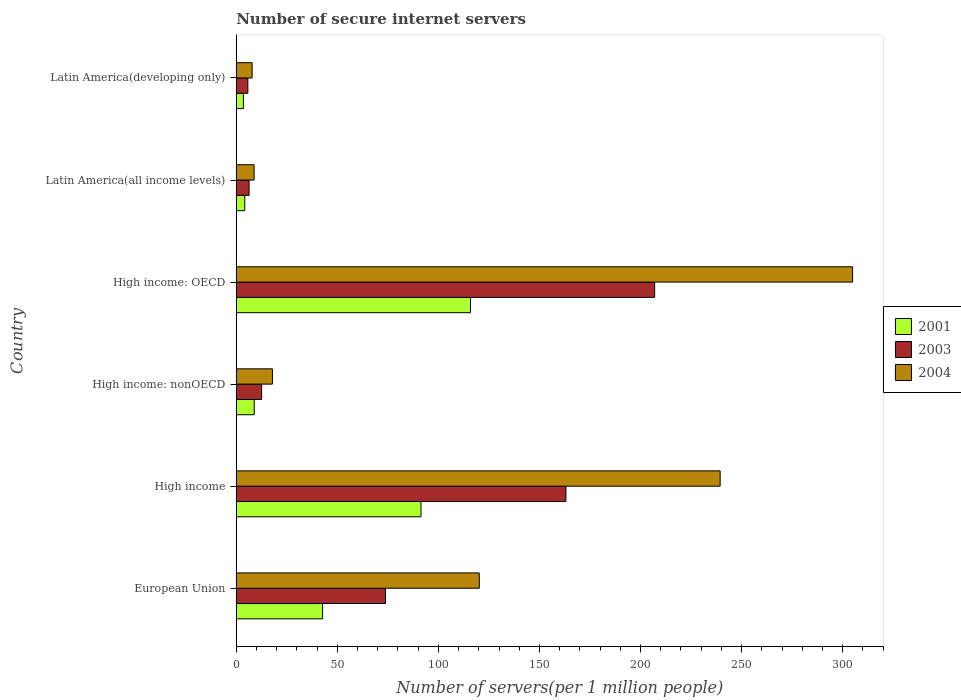How many groups of bars are there?
Your answer should be very brief. 6. What is the number of secure internet servers in 2004 in High income: nonOECD?
Your response must be concise. 17.9. Across all countries, what is the maximum number of secure internet servers in 2001?
Your answer should be compact. 115.88. Across all countries, what is the minimum number of secure internet servers in 2004?
Ensure brevity in your answer.  7.85. In which country was the number of secure internet servers in 2004 maximum?
Ensure brevity in your answer.  High income: OECD. In which country was the number of secure internet servers in 2003 minimum?
Make the answer very short. Latin America(developing only). What is the total number of secure internet servers in 2001 in the graph?
Your answer should be compact. 266.59. What is the difference between the number of secure internet servers in 2001 in High income and that in Latin America(developing only)?
Ensure brevity in your answer.  87.87. What is the difference between the number of secure internet servers in 2001 in Latin America(all income levels) and the number of secure internet servers in 2004 in High income: nonOECD?
Make the answer very short. -13.69. What is the average number of secure internet servers in 2004 per country?
Make the answer very short. 116.52. What is the difference between the number of secure internet servers in 2004 and number of secure internet servers in 2001 in European Union?
Make the answer very short. 77.51. What is the ratio of the number of secure internet servers in 2004 in High income: nonOECD to that in Latin America(developing only)?
Ensure brevity in your answer.  2.28. Is the difference between the number of secure internet servers in 2004 in High income: OECD and Latin America(all income levels) greater than the difference between the number of secure internet servers in 2001 in High income: OECD and Latin America(all income levels)?
Your answer should be compact. Yes. What is the difference between the highest and the second highest number of secure internet servers in 2003?
Your answer should be very brief. 43.9. What is the difference between the highest and the lowest number of secure internet servers in 2003?
Provide a short and direct response. 201.25. In how many countries, is the number of secure internet servers in 2004 greater than the average number of secure internet servers in 2004 taken over all countries?
Give a very brief answer. 3. Is the sum of the number of secure internet servers in 2001 in High income: OECD and Latin America(all income levels) greater than the maximum number of secure internet servers in 2004 across all countries?
Provide a succinct answer. No. What does the 2nd bar from the bottom in High income: nonOECD represents?
Make the answer very short. 2003. Is it the case that in every country, the sum of the number of secure internet servers in 2003 and number of secure internet servers in 2004 is greater than the number of secure internet servers in 2001?
Your answer should be compact. Yes. Where does the legend appear in the graph?
Make the answer very short. Center right. How are the legend labels stacked?
Your answer should be compact. Vertical. What is the title of the graph?
Provide a short and direct response. Number of secure internet servers. Does "1977" appear as one of the legend labels in the graph?
Give a very brief answer. No. What is the label or title of the X-axis?
Provide a short and direct response. Number of servers(per 1 million people). What is the label or title of the Y-axis?
Provide a succinct answer. Country. What is the Number of servers(per 1 million people) of 2001 in European Union?
Your answer should be compact. 42.71. What is the Number of servers(per 1 million people) of 2003 in European Union?
Offer a terse response. 73.83. What is the Number of servers(per 1 million people) of 2004 in European Union?
Your response must be concise. 120.23. What is the Number of servers(per 1 million people) in 2001 in High income?
Make the answer very short. 91.39. What is the Number of servers(per 1 million people) of 2003 in High income?
Keep it short and to the point. 163.09. What is the Number of servers(per 1 million people) in 2004 in High income?
Offer a terse response. 239.39. What is the Number of servers(per 1 million people) of 2001 in High income: nonOECD?
Your response must be concise. 8.88. What is the Number of servers(per 1 million people) in 2003 in High income: nonOECD?
Make the answer very short. 12.55. What is the Number of servers(per 1 million people) in 2004 in High income: nonOECD?
Make the answer very short. 17.9. What is the Number of servers(per 1 million people) of 2001 in High income: OECD?
Your answer should be compact. 115.88. What is the Number of servers(per 1 million people) of 2003 in High income: OECD?
Offer a very short reply. 206.98. What is the Number of servers(per 1 million people) in 2004 in High income: OECD?
Keep it short and to the point. 304.92. What is the Number of servers(per 1 million people) of 2001 in Latin America(all income levels)?
Your answer should be compact. 4.21. What is the Number of servers(per 1 million people) in 2003 in Latin America(all income levels)?
Your answer should be very brief. 6.35. What is the Number of servers(per 1 million people) of 2004 in Latin America(all income levels)?
Offer a very short reply. 8.83. What is the Number of servers(per 1 million people) in 2001 in Latin America(developing only)?
Your answer should be very brief. 3.52. What is the Number of servers(per 1 million people) in 2003 in Latin America(developing only)?
Your answer should be very brief. 5.73. What is the Number of servers(per 1 million people) in 2004 in Latin America(developing only)?
Give a very brief answer. 7.85. Across all countries, what is the maximum Number of servers(per 1 million people) in 2001?
Your answer should be compact. 115.88. Across all countries, what is the maximum Number of servers(per 1 million people) in 2003?
Provide a short and direct response. 206.98. Across all countries, what is the maximum Number of servers(per 1 million people) in 2004?
Keep it short and to the point. 304.92. Across all countries, what is the minimum Number of servers(per 1 million people) of 2001?
Offer a terse response. 3.52. Across all countries, what is the minimum Number of servers(per 1 million people) of 2003?
Provide a succinct answer. 5.73. Across all countries, what is the minimum Number of servers(per 1 million people) in 2004?
Your response must be concise. 7.85. What is the total Number of servers(per 1 million people) of 2001 in the graph?
Give a very brief answer. 266.59. What is the total Number of servers(per 1 million people) of 2003 in the graph?
Provide a short and direct response. 468.53. What is the total Number of servers(per 1 million people) in 2004 in the graph?
Give a very brief answer. 699.12. What is the difference between the Number of servers(per 1 million people) of 2001 in European Union and that in High income?
Your answer should be compact. -48.68. What is the difference between the Number of servers(per 1 million people) in 2003 in European Union and that in High income?
Provide a short and direct response. -89.26. What is the difference between the Number of servers(per 1 million people) in 2004 in European Union and that in High income?
Offer a very short reply. -119.16. What is the difference between the Number of servers(per 1 million people) of 2001 in European Union and that in High income: nonOECD?
Ensure brevity in your answer.  33.84. What is the difference between the Number of servers(per 1 million people) in 2003 in European Union and that in High income: nonOECD?
Offer a terse response. 61.28. What is the difference between the Number of servers(per 1 million people) in 2004 in European Union and that in High income: nonOECD?
Your answer should be compact. 102.32. What is the difference between the Number of servers(per 1 million people) in 2001 in European Union and that in High income: OECD?
Make the answer very short. -73.16. What is the difference between the Number of servers(per 1 million people) in 2003 in European Union and that in High income: OECD?
Make the answer very short. -133.16. What is the difference between the Number of servers(per 1 million people) in 2004 in European Union and that in High income: OECD?
Give a very brief answer. -184.7. What is the difference between the Number of servers(per 1 million people) in 2001 in European Union and that in Latin America(all income levels)?
Your answer should be very brief. 38.51. What is the difference between the Number of servers(per 1 million people) in 2003 in European Union and that in Latin America(all income levels)?
Ensure brevity in your answer.  67.48. What is the difference between the Number of servers(per 1 million people) in 2004 in European Union and that in Latin America(all income levels)?
Ensure brevity in your answer.  111.4. What is the difference between the Number of servers(per 1 million people) of 2001 in European Union and that in Latin America(developing only)?
Offer a terse response. 39.19. What is the difference between the Number of servers(per 1 million people) of 2003 in European Union and that in Latin America(developing only)?
Offer a very short reply. 68.1. What is the difference between the Number of servers(per 1 million people) in 2004 in European Union and that in Latin America(developing only)?
Offer a terse response. 112.38. What is the difference between the Number of servers(per 1 million people) of 2001 in High income and that in High income: nonOECD?
Give a very brief answer. 82.52. What is the difference between the Number of servers(per 1 million people) of 2003 in High income and that in High income: nonOECD?
Your answer should be very brief. 150.54. What is the difference between the Number of servers(per 1 million people) of 2004 in High income and that in High income: nonOECD?
Offer a very short reply. 221.49. What is the difference between the Number of servers(per 1 million people) in 2001 in High income and that in High income: OECD?
Provide a short and direct response. -24.49. What is the difference between the Number of servers(per 1 million people) in 2003 in High income and that in High income: OECD?
Give a very brief answer. -43.9. What is the difference between the Number of servers(per 1 million people) in 2004 in High income and that in High income: OECD?
Your response must be concise. -65.53. What is the difference between the Number of servers(per 1 million people) in 2001 in High income and that in Latin America(all income levels)?
Ensure brevity in your answer.  87.18. What is the difference between the Number of servers(per 1 million people) of 2003 in High income and that in Latin America(all income levels)?
Keep it short and to the point. 156.74. What is the difference between the Number of servers(per 1 million people) of 2004 in High income and that in Latin America(all income levels)?
Offer a very short reply. 230.56. What is the difference between the Number of servers(per 1 million people) in 2001 in High income and that in Latin America(developing only)?
Your answer should be compact. 87.87. What is the difference between the Number of servers(per 1 million people) in 2003 in High income and that in Latin America(developing only)?
Offer a very short reply. 157.36. What is the difference between the Number of servers(per 1 million people) in 2004 in High income and that in Latin America(developing only)?
Keep it short and to the point. 231.54. What is the difference between the Number of servers(per 1 million people) in 2001 in High income: nonOECD and that in High income: OECD?
Your answer should be compact. -107. What is the difference between the Number of servers(per 1 million people) of 2003 in High income: nonOECD and that in High income: OECD?
Your response must be concise. -194.43. What is the difference between the Number of servers(per 1 million people) of 2004 in High income: nonOECD and that in High income: OECD?
Keep it short and to the point. -287.02. What is the difference between the Number of servers(per 1 million people) in 2001 in High income: nonOECD and that in Latin America(all income levels)?
Provide a succinct answer. 4.67. What is the difference between the Number of servers(per 1 million people) in 2003 in High income: nonOECD and that in Latin America(all income levels)?
Give a very brief answer. 6.2. What is the difference between the Number of servers(per 1 million people) in 2004 in High income: nonOECD and that in Latin America(all income levels)?
Your response must be concise. 9.07. What is the difference between the Number of servers(per 1 million people) of 2001 in High income: nonOECD and that in Latin America(developing only)?
Provide a succinct answer. 5.35. What is the difference between the Number of servers(per 1 million people) of 2003 in High income: nonOECD and that in Latin America(developing only)?
Provide a short and direct response. 6.82. What is the difference between the Number of servers(per 1 million people) of 2004 in High income: nonOECD and that in Latin America(developing only)?
Provide a short and direct response. 10.05. What is the difference between the Number of servers(per 1 million people) of 2001 in High income: OECD and that in Latin America(all income levels)?
Offer a terse response. 111.67. What is the difference between the Number of servers(per 1 million people) in 2003 in High income: OECD and that in Latin America(all income levels)?
Ensure brevity in your answer.  200.64. What is the difference between the Number of servers(per 1 million people) in 2004 in High income: OECD and that in Latin America(all income levels)?
Provide a succinct answer. 296.09. What is the difference between the Number of servers(per 1 million people) of 2001 in High income: OECD and that in Latin America(developing only)?
Give a very brief answer. 112.36. What is the difference between the Number of servers(per 1 million people) in 2003 in High income: OECD and that in Latin America(developing only)?
Your response must be concise. 201.25. What is the difference between the Number of servers(per 1 million people) of 2004 in High income: OECD and that in Latin America(developing only)?
Your answer should be compact. 297.07. What is the difference between the Number of servers(per 1 million people) in 2001 in Latin America(all income levels) and that in Latin America(developing only)?
Your response must be concise. 0.69. What is the difference between the Number of servers(per 1 million people) in 2003 in Latin America(all income levels) and that in Latin America(developing only)?
Make the answer very short. 0.61. What is the difference between the Number of servers(per 1 million people) in 2004 in Latin America(all income levels) and that in Latin America(developing only)?
Provide a succinct answer. 0.98. What is the difference between the Number of servers(per 1 million people) in 2001 in European Union and the Number of servers(per 1 million people) in 2003 in High income?
Your answer should be compact. -120.37. What is the difference between the Number of servers(per 1 million people) in 2001 in European Union and the Number of servers(per 1 million people) in 2004 in High income?
Give a very brief answer. -196.68. What is the difference between the Number of servers(per 1 million people) in 2003 in European Union and the Number of servers(per 1 million people) in 2004 in High income?
Offer a terse response. -165.56. What is the difference between the Number of servers(per 1 million people) of 2001 in European Union and the Number of servers(per 1 million people) of 2003 in High income: nonOECD?
Ensure brevity in your answer.  30.16. What is the difference between the Number of servers(per 1 million people) in 2001 in European Union and the Number of servers(per 1 million people) in 2004 in High income: nonOECD?
Provide a succinct answer. 24.81. What is the difference between the Number of servers(per 1 million people) in 2003 in European Union and the Number of servers(per 1 million people) in 2004 in High income: nonOECD?
Offer a terse response. 55.93. What is the difference between the Number of servers(per 1 million people) of 2001 in European Union and the Number of servers(per 1 million people) of 2003 in High income: OECD?
Make the answer very short. -164.27. What is the difference between the Number of servers(per 1 million people) of 2001 in European Union and the Number of servers(per 1 million people) of 2004 in High income: OECD?
Your answer should be compact. -262.21. What is the difference between the Number of servers(per 1 million people) in 2003 in European Union and the Number of servers(per 1 million people) in 2004 in High income: OECD?
Ensure brevity in your answer.  -231.09. What is the difference between the Number of servers(per 1 million people) of 2001 in European Union and the Number of servers(per 1 million people) of 2003 in Latin America(all income levels)?
Provide a short and direct response. 36.37. What is the difference between the Number of servers(per 1 million people) in 2001 in European Union and the Number of servers(per 1 million people) in 2004 in Latin America(all income levels)?
Offer a terse response. 33.88. What is the difference between the Number of servers(per 1 million people) of 2003 in European Union and the Number of servers(per 1 million people) of 2004 in Latin America(all income levels)?
Keep it short and to the point. 65. What is the difference between the Number of servers(per 1 million people) in 2001 in European Union and the Number of servers(per 1 million people) in 2003 in Latin America(developing only)?
Provide a succinct answer. 36.98. What is the difference between the Number of servers(per 1 million people) in 2001 in European Union and the Number of servers(per 1 million people) in 2004 in Latin America(developing only)?
Ensure brevity in your answer.  34.86. What is the difference between the Number of servers(per 1 million people) in 2003 in European Union and the Number of servers(per 1 million people) in 2004 in Latin America(developing only)?
Provide a short and direct response. 65.98. What is the difference between the Number of servers(per 1 million people) in 2001 in High income and the Number of servers(per 1 million people) in 2003 in High income: nonOECD?
Provide a short and direct response. 78.84. What is the difference between the Number of servers(per 1 million people) of 2001 in High income and the Number of servers(per 1 million people) of 2004 in High income: nonOECD?
Your answer should be compact. 73.49. What is the difference between the Number of servers(per 1 million people) in 2003 in High income and the Number of servers(per 1 million people) in 2004 in High income: nonOECD?
Make the answer very short. 145.18. What is the difference between the Number of servers(per 1 million people) in 2001 in High income and the Number of servers(per 1 million people) in 2003 in High income: OECD?
Give a very brief answer. -115.59. What is the difference between the Number of servers(per 1 million people) of 2001 in High income and the Number of servers(per 1 million people) of 2004 in High income: OECD?
Offer a terse response. -213.53. What is the difference between the Number of servers(per 1 million people) of 2003 in High income and the Number of servers(per 1 million people) of 2004 in High income: OECD?
Offer a very short reply. -141.83. What is the difference between the Number of servers(per 1 million people) in 2001 in High income and the Number of servers(per 1 million people) in 2003 in Latin America(all income levels)?
Your response must be concise. 85.05. What is the difference between the Number of servers(per 1 million people) in 2001 in High income and the Number of servers(per 1 million people) in 2004 in Latin America(all income levels)?
Offer a terse response. 82.56. What is the difference between the Number of servers(per 1 million people) of 2003 in High income and the Number of servers(per 1 million people) of 2004 in Latin America(all income levels)?
Your answer should be compact. 154.26. What is the difference between the Number of servers(per 1 million people) in 2001 in High income and the Number of servers(per 1 million people) in 2003 in Latin America(developing only)?
Your answer should be very brief. 85.66. What is the difference between the Number of servers(per 1 million people) in 2001 in High income and the Number of servers(per 1 million people) in 2004 in Latin America(developing only)?
Provide a succinct answer. 83.54. What is the difference between the Number of servers(per 1 million people) in 2003 in High income and the Number of servers(per 1 million people) in 2004 in Latin America(developing only)?
Offer a very short reply. 155.24. What is the difference between the Number of servers(per 1 million people) in 2001 in High income: nonOECD and the Number of servers(per 1 million people) in 2003 in High income: OECD?
Keep it short and to the point. -198.11. What is the difference between the Number of servers(per 1 million people) of 2001 in High income: nonOECD and the Number of servers(per 1 million people) of 2004 in High income: OECD?
Your response must be concise. -296.05. What is the difference between the Number of servers(per 1 million people) in 2003 in High income: nonOECD and the Number of servers(per 1 million people) in 2004 in High income: OECD?
Offer a terse response. -292.37. What is the difference between the Number of servers(per 1 million people) in 2001 in High income: nonOECD and the Number of servers(per 1 million people) in 2003 in Latin America(all income levels)?
Your response must be concise. 2.53. What is the difference between the Number of servers(per 1 million people) in 2001 in High income: nonOECD and the Number of servers(per 1 million people) in 2004 in Latin America(all income levels)?
Provide a succinct answer. 0.05. What is the difference between the Number of servers(per 1 million people) in 2003 in High income: nonOECD and the Number of servers(per 1 million people) in 2004 in Latin America(all income levels)?
Provide a succinct answer. 3.72. What is the difference between the Number of servers(per 1 million people) of 2001 in High income: nonOECD and the Number of servers(per 1 million people) of 2003 in Latin America(developing only)?
Your answer should be compact. 3.14. What is the difference between the Number of servers(per 1 million people) in 2001 in High income: nonOECD and the Number of servers(per 1 million people) in 2004 in Latin America(developing only)?
Provide a short and direct response. 1.03. What is the difference between the Number of servers(per 1 million people) in 2003 in High income: nonOECD and the Number of servers(per 1 million people) in 2004 in Latin America(developing only)?
Keep it short and to the point. 4.7. What is the difference between the Number of servers(per 1 million people) of 2001 in High income: OECD and the Number of servers(per 1 million people) of 2003 in Latin America(all income levels)?
Offer a terse response. 109.53. What is the difference between the Number of servers(per 1 million people) of 2001 in High income: OECD and the Number of servers(per 1 million people) of 2004 in Latin America(all income levels)?
Provide a succinct answer. 107.05. What is the difference between the Number of servers(per 1 million people) of 2003 in High income: OECD and the Number of servers(per 1 million people) of 2004 in Latin America(all income levels)?
Your response must be concise. 198.15. What is the difference between the Number of servers(per 1 million people) in 2001 in High income: OECD and the Number of servers(per 1 million people) in 2003 in Latin America(developing only)?
Provide a short and direct response. 110.15. What is the difference between the Number of servers(per 1 million people) of 2001 in High income: OECD and the Number of servers(per 1 million people) of 2004 in Latin America(developing only)?
Provide a short and direct response. 108.03. What is the difference between the Number of servers(per 1 million people) of 2003 in High income: OECD and the Number of servers(per 1 million people) of 2004 in Latin America(developing only)?
Give a very brief answer. 199.13. What is the difference between the Number of servers(per 1 million people) of 2001 in Latin America(all income levels) and the Number of servers(per 1 million people) of 2003 in Latin America(developing only)?
Give a very brief answer. -1.52. What is the difference between the Number of servers(per 1 million people) of 2001 in Latin America(all income levels) and the Number of servers(per 1 million people) of 2004 in Latin America(developing only)?
Make the answer very short. -3.64. What is the difference between the Number of servers(per 1 million people) in 2003 in Latin America(all income levels) and the Number of servers(per 1 million people) in 2004 in Latin America(developing only)?
Your response must be concise. -1.5. What is the average Number of servers(per 1 million people) of 2001 per country?
Provide a short and direct response. 44.43. What is the average Number of servers(per 1 million people) of 2003 per country?
Offer a terse response. 78.09. What is the average Number of servers(per 1 million people) of 2004 per country?
Provide a short and direct response. 116.52. What is the difference between the Number of servers(per 1 million people) in 2001 and Number of servers(per 1 million people) in 2003 in European Union?
Keep it short and to the point. -31.11. What is the difference between the Number of servers(per 1 million people) of 2001 and Number of servers(per 1 million people) of 2004 in European Union?
Offer a very short reply. -77.51. What is the difference between the Number of servers(per 1 million people) of 2003 and Number of servers(per 1 million people) of 2004 in European Union?
Provide a short and direct response. -46.4. What is the difference between the Number of servers(per 1 million people) of 2001 and Number of servers(per 1 million people) of 2003 in High income?
Your answer should be compact. -71.7. What is the difference between the Number of servers(per 1 million people) in 2001 and Number of servers(per 1 million people) in 2004 in High income?
Your answer should be compact. -148. What is the difference between the Number of servers(per 1 million people) of 2003 and Number of servers(per 1 million people) of 2004 in High income?
Your answer should be compact. -76.3. What is the difference between the Number of servers(per 1 million people) in 2001 and Number of servers(per 1 million people) in 2003 in High income: nonOECD?
Provide a succinct answer. -3.67. What is the difference between the Number of servers(per 1 million people) in 2001 and Number of servers(per 1 million people) in 2004 in High income: nonOECD?
Your answer should be compact. -9.03. What is the difference between the Number of servers(per 1 million people) in 2003 and Number of servers(per 1 million people) in 2004 in High income: nonOECD?
Ensure brevity in your answer.  -5.35. What is the difference between the Number of servers(per 1 million people) in 2001 and Number of servers(per 1 million people) in 2003 in High income: OECD?
Your response must be concise. -91.11. What is the difference between the Number of servers(per 1 million people) in 2001 and Number of servers(per 1 million people) in 2004 in High income: OECD?
Keep it short and to the point. -189.04. What is the difference between the Number of servers(per 1 million people) in 2003 and Number of servers(per 1 million people) in 2004 in High income: OECD?
Your response must be concise. -97.94. What is the difference between the Number of servers(per 1 million people) of 2001 and Number of servers(per 1 million people) of 2003 in Latin America(all income levels)?
Give a very brief answer. -2.14. What is the difference between the Number of servers(per 1 million people) in 2001 and Number of servers(per 1 million people) in 2004 in Latin America(all income levels)?
Provide a succinct answer. -4.62. What is the difference between the Number of servers(per 1 million people) in 2003 and Number of servers(per 1 million people) in 2004 in Latin America(all income levels)?
Your response must be concise. -2.48. What is the difference between the Number of servers(per 1 million people) in 2001 and Number of servers(per 1 million people) in 2003 in Latin America(developing only)?
Offer a very short reply. -2.21. What is the difference between the Number of servers(per 1 million people) in 2001 and Number of servers(per 1 million people) in 2004 in Latin America(developing only)?
Give a very brief answer. -4.33. What is the difference between the Number of servers(per 1 million people) in 2003 and Number of servers(per 1 million people) in 2004 in Latin America(developing only)?
Give a very brief answer. -2.12. What is the ratio of the Number of servers(per 1 million people) in 2001 in European Union to that in High income?
Make the answer very short. 0.47. What is the ratio of the Number of servers(per 1 million people) in 2003 in European Union to that in High income?
Offer a very short reply. 0.45. What is the ratio of the Number of servers(per 1 million people) in 2004 in European Union to that in High income?
Give a very brief answer. 0.5. What is the ratio of the Number of servers(per 1 million people) in 2001 in European Union to that in High income: nonOECD?
Keep it short and to the point. 4.81. What is the ratio of the Number of servers(per 1 million people) of 2003 in European Union to that in High income: nonOECD?
Ensure brevity in your answer.  5.88. What is the ratio of the Number of servers(per 1 million people) in 2004 in European Union to that in High income: nonOECD?
Ensure brevity in your answer.  6.72. What is the ratio of the Number of servers(per 1 million people) in 2001 in European Union to that in High income: OECD?
Keep it short and to the point. 0.37. What is the ratio of the Number of servers(per 1 million people) of 2003 in European Union to that in High income: OECD?
Your answer should be compact. 0.36. What is the ratio of the Number of servers(per 1 million people) in 2004 in European Union to that in High income: OECD?
Offer a very short reply. 0.39. What is the ratio of the Number of servers(per 1 million people) of 2001 in European Union to that in Latin America(all income levels)?
Provide a short and direct response. 10.15. What is the ratio of the Number of servers(per 1 million people) in 2003 in European Union to that in Latin America(all income levels)?
Give a very brief answer. 11.63. What is the ratio of the Number of servers(per 1 million people) in 2004 in European Union to that in Latin America(all income levels)?
Your answer should be very brief. 13.61. What is the ratio of the Number of servers(per 1 million people) in 2001 in European Union to that in Latin America(developing only)?
Your answer should be compact. 12.13. What is the ratio of the Number of servers(per 1 million people) in 2003 in European Union to that in Latin America(developing only)?
Provide a succinct answer. 12.88. What is the ratio of the Number of servers(per 1 million people) in 2004 in European Union to that in Latin America(developing only)?
Ensure brevity in your answer.  15.31. What is the ratio of the Number of servers(per 1 million people) of 2001 in High income to that in High income: nonOECD?
Your answer should be very brief. 10.3. What is the ratio of the Number of servers(per 1 million people) in 2003 in High income to that in High income: nonOECD?
Give a very brief answer. 13. What is the ratio of the Number of servers(per 1 million people) in 2004 in High income to that in High income: nonOECD?
Provide a succinct answer. 13.37. What is the ratio of the Number of servers(per 1 million people) of 2001 in High income to that in High income: OECD?
Make the answer very short. 0.79. What is the ratio of the Number of servers(per 1 million people) in 2003 in High income to that in High income: OECD?
Make the answer very short. 0.79. What is the ratio of the Number of servers(per 1 million people) in 2004 in High income to that in High income: OECD?
Ensure brevity in your answer.  0.79. What is the ratio of the Number of servers(per 1 million people) of 2001 in High income to that in Latin America(all income levels)?
Keep it short and to the point. 21.72. What is the ratio of the Number of servers(per 1 million people) in 2003 in High income to that in Latin America(all income levels)?
Provide a succinct answer. 25.7. What is the ratio of the Number of servers(per 1 million people) in 2004 in High income to that in Latin America(all income levels)?
Offer a terse response. 27.11. What is the ratio of the Number of servers(per 1 million people) in 2001 in High income to that in Latin America(developing only)?
Your answer should be compact. 25.95. What is the ratio of the Number of servers(per 1 million people) of 2003 in High income to that in Latin America(developing only)?
Give a very brief answer. 28.46. What is the ratio of the Number of servers(per 1 million people) of 2004 in High income to that in Latin America(developing only)?
Offer a very short reply. 30.49. What is the ratio of the Number of servers(per 1 million people) in 2001 in High income: nonOECD to that in High income: OECD?
Ensure brevity in your answer.  0.08. What is the ratio of the Number of servers(per 1 million people) in 2003 in High income: nonOECD to that in High income: OECD?
Provide a succinct answer. 0.06. What is the ratio of the Number of servers(per 1 million people) in 2004 in High income: nonOECD to that in High income: OECD?
Your response must be concise. 0.06. What is the ratio of the Number of servers(per 1 million people) in 2001 in High income: nonOECD to that in Latin America(all income levels)?
Ensure brevity in your answer.  2.11. What is the ratio of the Number of servers(per 1 million people) in 2003 in High income: nonOECD to that in Latin America(all income levels)?
Offer a terse response. 1.98. What is the ratio of the Number of servers(per 1 million people) of 2004 in High income: nonOECD to that in Latin America(all income levels)?
Provide a short and direct response. 2.03. What is the ratio of the Number of servers(per 1 million people) in 2001 in High income: nonOECD to that in Latin America(developing only)?
Offer a very short reply. 2.52. What is the ratio of the Number of servers(per 1 million people) in 2003 in High income: nonOECD to that in Latin America(developing only)?
Offer a terse response. 2.19. What is the ratio of the Number of servers(per 1 million people) in 2004 in High income: nonOECD to that in Latin America(developing only)?
Provide a succinct answer. 2.28. What is the ratio of the Number of servers(per 1 million people) of 2001 in High income: OECD to that in Latin America(all income levels)?
Offer a terse response. 27.53. What is the ratio of the Number of servers(per 1 million people) of 2003 in High income: OECD to that in Latin America(all income levels)?
Your answer should be very brief. 32.62. What is the ratio of the Number of servers(per 1 million people) of 2004 in High income: OECD to that in Latin America(all income levels)?
Give a very brief answer. 34.53. What is the ratio of the Number of servers(per 1 million people) in 2001 in High income: OECD to that in Latin America(developing only)?
Your answer should be compact. 32.9. What is the ratio of the Number of servers(per 1 million people) of 2003 in High income: OECD to that in Latin America(developing only)?
Your answer should be compact. 36.11. What is the ratio of the Number of servers(per 1 million people) of 2004 in High income: OECD to that in Latin America(developing only)?
Your response must be concise. 38.84. What is the ratio of the Number of servers(per 1 million people) in 2001 in Latin America(all income levels) to that in Latin America(developing only)?
Your answer should be compact. 1.19. What is the ratio of the Number of servers(per 1 million people) of 2003 in Latin America(all income levels) to that in Latin America(developing only)?
Provide a succinct answer. 1.11. What is the ratio of the Number of servers(per 1 million people) of 2004 in Latin America(all income levels) to that in Latin America(developing only)?
Keep it short and to the point. 1.12. What is the difference between the highest and the second highest Number of servers(per 1 million people) in 2001?
Offer a terse response. 24.49. What is the difference between the highest and the second highest Number of servers(per 1 million people) in 2003?
Provide a succinct answer. 43.9. What is the difference between the highest and the second highest Number of servers(per 1 million people) in 2004?
Offer a terse response. 65.53. What is the difference between the highest and the lowest Number of servers(per 1 million people) of 2001?
Keep it short and to the point. 112.36. What is the difference between the highest and the lowest Number of servers(per 1 million people) in 2003?
Ensure brevity in your answer.  201.25. What is the difference between the highest and the lowest Number of servers(per 1 million people) in 2004?
Give a very brief answer. 297.07. 